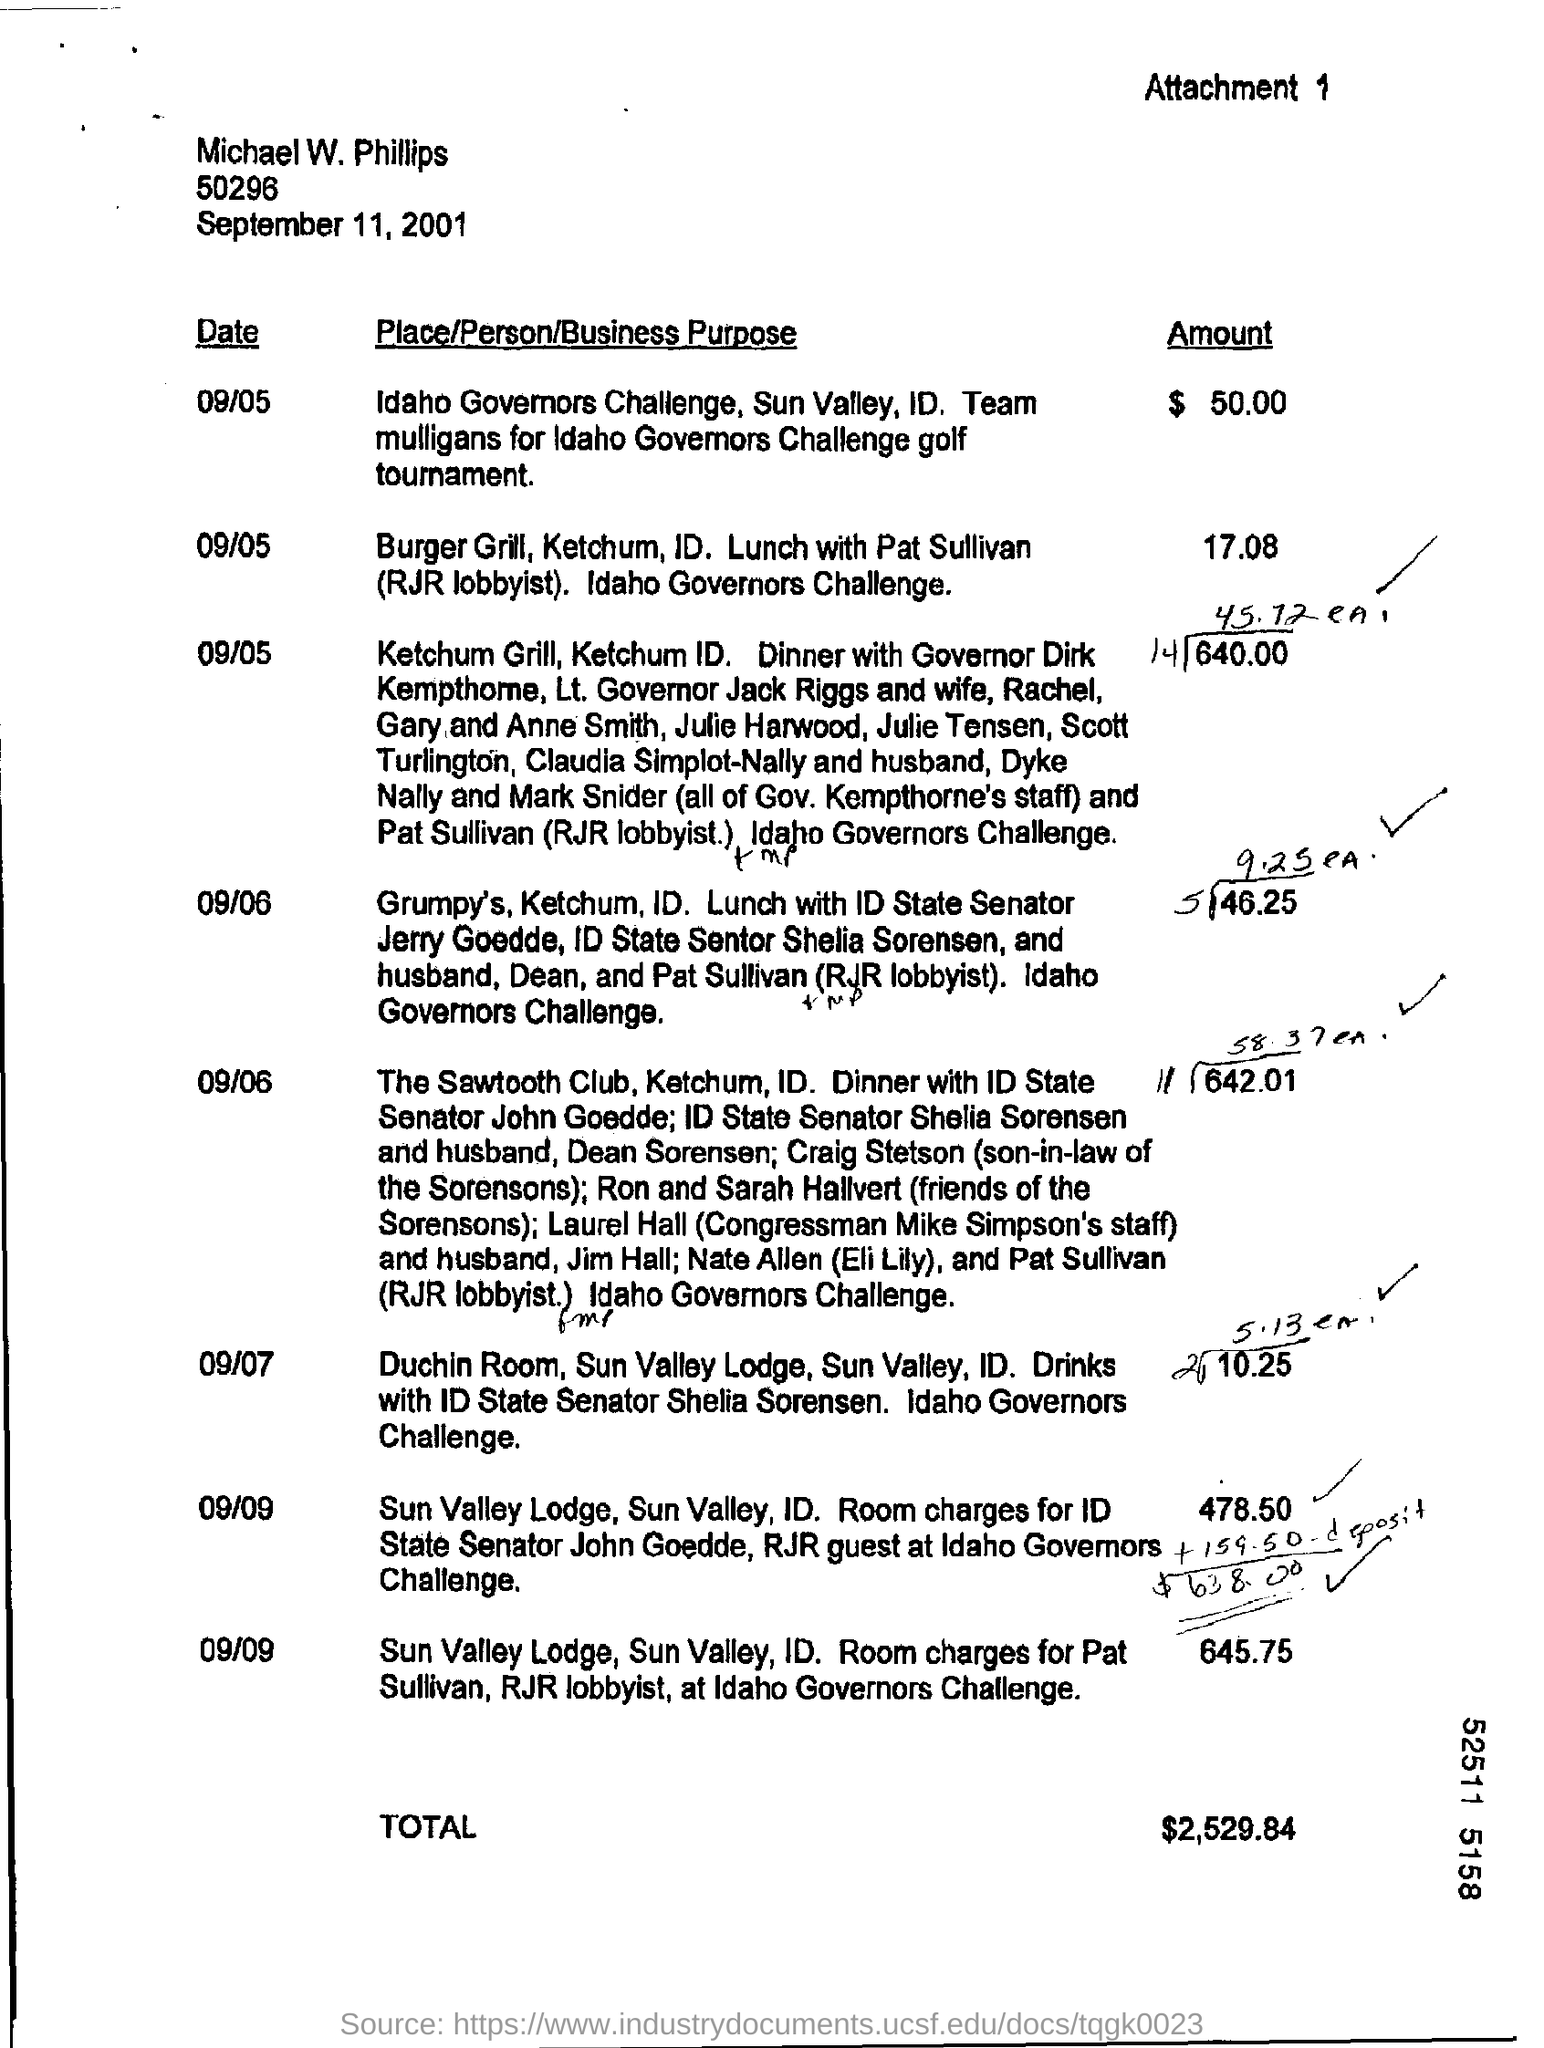Specify some key components in this picture. For the day of September 7th, the total amount is 10.25. 